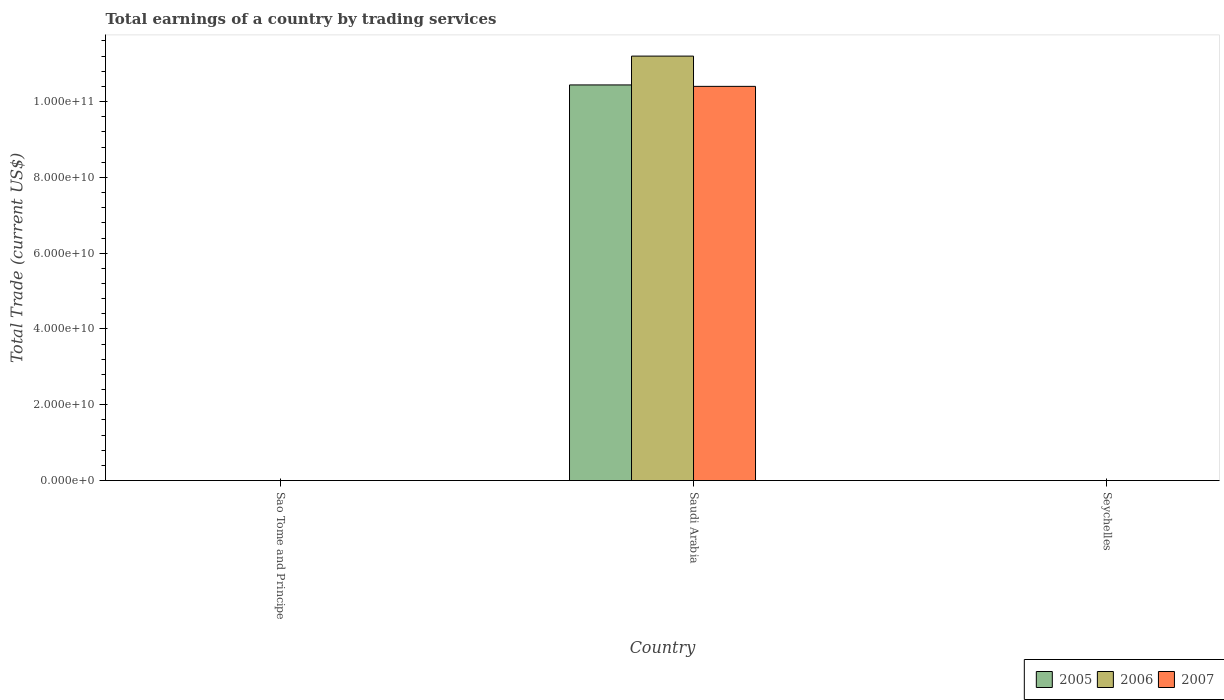Are the number of bars on each tick of the X-axis equal?
Offer a very short reply. No. How many bars are there on the 2nd tick from the left?
Make the answer very short. 3. How many bars are there on the 2nd tick from the right?
Your response must be concise. 3. What is the label of the 3rd group of bars from the left?
Make the answer very short. Seychelles. In how many cases, is the number of bars for a given country not equal to the number of legend labels?
Give a very brief answer. 2. What is the total earnings in 2007 in Sao Tome and Principe?
Keep it short and to the point. 0. Across all countries, what is the maximum total earnings in 2007?
Offer a terse response. 1.04e+11. In which country was the total earnings in 2007 maximum?
Provide a short and direct response. Saudi Arabia. What is the total total earnings in 2007 in the graph?
Ensure brevity in your answer.  1.04e+11. What is the average total earnings in 2007 per country?
Ensure brevity in your answer.  3.47e+1. What is the difference between the total earnings of/in 2006 and total earnings of/in 2007 in Saudi Arabia?
Ensure brevity in your answer.  7.99e+09. What is the difference between the highest and the lowest total earnings in 2005?
Your response must be concise. 1.04e+11. Is it the case that in every country, the sum of the total earnings in 2005 and total earnings in 2006 is greater than the total earnings in 2007?
Your answer should be compact. No. Are all the bars in the graph horizontal?
Provide a short and direct response. No. What is the title of the graph?
Provide a succinct answer. Total earnings of a country by trading services. What is the label or title of the X-axis?
Ensure brevity in your answer.  Country. What is the label or title of the Y-axis?
Provide a succinct answer. Total Trade (current US$). What is the Total Trade (current US$) in 2006 in Sao Tome and Principe?
Offer a very short reply. 0. What is the Total Trade (current US$) in 2007 in Sao Tome and Principe?
Give a very brief answer. 0. What is the Total Trade (current US$) of 2005 in Saudi Arabia?
Ensure brevity in your answer.  1.04e+11. What is the Total Trade (current US$) of 2006 in Saudi Arabia?
Provide a succinct answer. 1.12e+11. What is the Total Trade (current US$) of 2007 in Saudi Arabia?
Ensure brevity in your answer.  1.04e+11. What is the Total Trade (current US$) in 2006 in Seychelles?
Provide a short and direct response. 0. Across all countries, what is the maximum Total Trade (current US$) in 2005?
Give a very brief answer. 1.04e+11. Across all countries, what is the maximum Total Trade (current US$) of 2006?
Give a very brief answer. 1.12e+11. Across all countries, what is the maximum Total Trade (current US$) in 2007?
Your answer should be compact. 1.04e+11. Across all countries, what is the minimum Total Trade (current US$) in 2005?
Offer a very short reply. 0. Across all countries, what is the minimum Total Trade (current US$) of 2006?
Make the answer very short. 0. Across all countries, what is the minimum Total Trade (current US$) in 2007?
Offer a terse response. 0. What is the total Total Trade (current US$) in 2005 in the graph?
Give a very brief answer. 1.04e+11. What is the total Total Trade (current US$) in 2006 in the graph?
Provide a short and direct response. 1.12e+11. What is the total Total Trade (current US$) in 2007 in the graph?
Offer a terse response. 1.04e+11. What is the average Total Trade (current US$) in 2005 per country?
Your response must be concise. 3.48e+1. What is the average Total Trade (current US$) of 2006 per country?
Keep it short and to the point. 3.73e+1. What is the average Total Trade (current US$) in 2007 per country?
Make the answer very short. 3.47e+1. What is the difference between the Total Trade (current US$) of 2005 and Total Trade (current US$) of 2006 in Saudi Arabia?
Your response must be concise. -7.61e+09. What is the difference between the Total Trade (current US$) in 2005 and Total Trade (current US$) in 2007 in Saudi Arabia?
Your answer should be very brief. 3.80e+08. What is the difference between the Total Trade (current US$) of 2006 and Total Trade (current US$) of 2007 in Saudi Arabia?
Keep it short and to the point. 7.99e+09. What is the difference between the highest and the lowest Total Trade (current US$) in 2005?
Your answer should be compact. 1.04e+11. What is the difference between the highest and the lowest Total Trade (current US$) in 2006?
Provide a short and direct response. 1.12e+11. What is the difference between the highest and the lowest Total Trade (current US$) in 2007?
Give a very brief answer. 1.04e+11. 